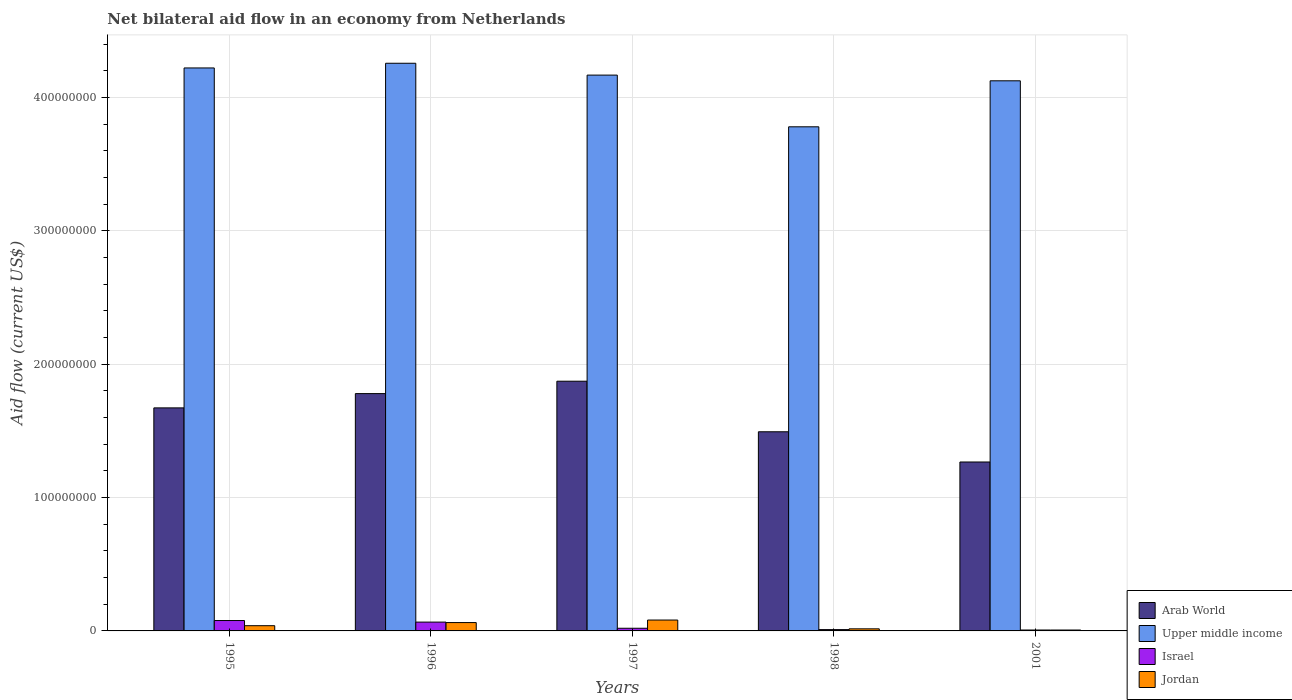Are the number of bars per tick equal to the number of legend labels?
Your response must be concise. Yes. Are the number of bars on each tick of the X-axis equal?
Give a very brief answer. Yes. How many bars are there on the 3rd tick from the right?
Your answer should be compact. 4. What is the net bilateral aid flow in Israel in 1998?
Provide a short and direct response. 9.90e+05. Across all years, what is the maximum net bilateral aid flow in Arab World?
Provide a short and direct response. 1.87e+08. Across all years, what is the minimum net bilateral aid flow in Jordan?
Ensure brevity in your answer.  6.70e+05. In which year was the net bilateral aid flow in Arab World maximum?
Make the answer very short. 1997. In which year was the net bilateral aid flow in Upper middle income minimum?
Keep it short and to the point. 1998. What is the total net bilateral aid flow in Jordan in the graph?
Ensure brevity in your answer.  2.06e+07. What is the difference between the net bilateral aid flow in Israel in 1997 and that in 2001?
Ensure brevity in your answer.  1.31e+06. What is the difference between the net bilateral aid flow in Jordan in 1997 and the net bilateral aid flow in Israel in 1996?
Your answer should be very brief. 1.54e+06. What is the average net bilateral aid flow in Upper middle income per year?
Your answer should be compact. 4.11e+08. In the year 1998, what is the difference between the net bilateral aid flow in Arab World and net bilateral aid flow in Israel?
Keep it short and to the point. 1.48e+08. What is the ratio of the net bilateral aid flow in Arab World in 1996 to that in 2001?
Your answer should be compact. 1.4. Is the difference between the net bilateral aid flow in Arab World in 1995 and 2001 greater than the difference between the net bilateral aid flow in Israel in 1995 and 2001?
Make the answer very short. Yes. What is the difference between the highest and the second highest net bilateral aid flow in Upper middle income?
Keep it short and to the point. 3.52e+06. What is the difference between the highest and the lowest net bilateral aid flow in Israel?
Ensure brevity in your answer.  7.11e+06. In how many years, is the net bilateral aid flow in Arab World greater than the average net bilateral aid flow in Arab World taken over all years?
Your response must be concise. 3. Is the sum of the net bilateral aid flow in Upper middle income in 1996 and 1997 greater than the maximum net bilateral aid flow in Arab World across all years?
Ensure brevity in your answer.  Yes. Is it the case that in every year, the sum of the net bilateral aid flow in Jordan and net bilateral aid flow in Israel is greater than the sum of net bilateral aid flow in Arab World and net bilateral aid flow in Upper middle income?
Keep it short and to the point. No. What does the 3rd bar from the right in 1997 represents?
Offer a terse response. Upper middle income. How many years are there in the graph?
Your response must be concise. 5. What is the difference between two consecutive major ticks on the Y-axis?
Provide a short and direct response. 1.00e+08. Are the values on the major ticks of Y-axis written in scientific E-notation?
Give a very brief answer. No. Does the graph contain grids?
Your response must be concise. Yes. How many legend labels are there?
Ensure brevity in your answer.  4. How are the legend labels stacked?
Make the answer very short. Vertical. What is the title of the graph?
Your response must be concise. Net bilateral aid flow in an economy from Netherlands. Does "Virgin Islands" appear as one of the legend labels in the graph?
Ensure brevity in your answer.  No. What is the Aid flow (current US$) in Arab World in 1995?
Make the answer very short. 1.67e+08. What is the Aid flow (current US$) of Upper middle income in 1995?
Your answer should be compact. 4.22e+08. What is the Aid flow (current US$) in Israel in 1995?
Make the answer very short. 7.80e+06. What is the Aid flow (current US$) in Jordan in 1995?
Provide a short and direct response. 3.92e+06. What is the Aid flow (current US$) of Arab World in 1996?
Your answer should be compact. 1.78e+08. What is the Aid flow (current US$) in Upper middle income in 1996?
Your response must be concise. 4.26e+08. What is the Aid flow (current US$) in Israel in 1996?
Ensure brevity in your answer.  6.62e+06. What is the Aid flow (current US$) in Jordan in 1996?
Your response must be concise. 6.26e+06. What is the Aid flow (current US$) of Arab World in 1997?
Your response must be concise. 1.87e+08. What is the Aid flow (current US$) of Upper middle income in 1997?
Offer a terse response. 4.17e+08. What is the Aid flow (current US$) in Jordan in 1997?
Provide a short and direct response. 8.16e+06. What is the Aid flow (current US$) of Arab World in 1998?
Give a very brief answer. 1.49e+08. What is the Aid flow (current US$) of Upper middle income in 1998?
Give a very brief answer. 3.78e+08. What is the Aid flow (current US$) in Israel in 1998?
Offer a terse response. 9.90e+05. What is the Aid flow (current US$) of Jordan in 1998?
Keep it short and to the point. 1.56e+06. What is the Aid flow (current US$) of Arab World in 2001?
Your answer should be compact. 1.27e+08. What is the Aid flow (current US$) in Upper middle income in 2001?
Provide a short and direct response. 4.13e+08. What is the Aid flow (current US$) of Israel in 2001?
Provide a succinct answer. 6.90e+05. What is the Aid flow (current US$) in Jordan in 2001?
Offer a very short reply. 6.70e+05. Across all years, what is the maximum Aid flow (current US$) of Arab World?
Provide a short and direct response. 1.87e+08. Across all years, what is the maximum Aid flow (current US$) in Upper middle income?
Your answer should be very brief. 4.26e+08. Across all years, what is the maximum Aid flow (current US$) of Israel?
Your answer should be very brief. 7.80e+06. Across all years, what is the maximum Aid flow (current US$) in Jordan?
Ensure brevity in your answer.  8.16e+06. Across all years, what is the minimum Aid flow (current US$) of Arab World?
Your answer should be compact. 1.27e+08. Across all years, what is the minimum Aid flow (current US$) in Upper middle income?
Offer a very short reply. 3.78e+08. Across all years, what is the minimum Aid flow (current US$) in Israel?
Offer a terse response. 6.90e+05. Across all years, what is the minimum Aid flow (current US$) in Jordan?
Ensure brevity in your answer.  6.70e+05. What is the total Aid flow (current US$) in Arab World in the graph?
Ensure brevity in your answer.  8.09e+08. What is the total Aid flow (current US$) of Upper middle income in the graph?
Your response must be concise. 2.06e+09. What is the total Aid flow (current US$) of Israel in the graph?
Ensure brevity in your answer.  1.81e+07. What is the total Aid flow (current US$) in Jordan in the graph?
Ensure brevity in your answer.  2.06e+07. What is the difference between the Aid flow (current US$) in Arab World in 1995 and that in 1996?
Offer a terse response. -1.07e+07. What is the difference between the Aid flow (current US$) of Upper middle income in 1995 and that in 1996?
Offer a terse response. -3.52e+06. What is the difference between the Aid flow (current US$) of Israel in 1995 and that in 1996?
Your answer should be very brief. 1.18e+06. What is the difference between the Aid flow (current US$) in Jordan in 1995 and that in 1996?
Provide a short and direct response. -2.34e+06. What is the difference between the Aid flow (current US$) of Arab World in 1995 and that in 1997?
Offer a terse response. -2.00e+07. What is the difference between the Aid flow (current US$) of Upper middle income in 1995 and that in 1997?
Provide a short and direct response. 5.36e+06. What is the difference between the Aid flow (current US$) in Israel in 1995 and that in 1997?
Your answer should be very brief. 5.80e+06. What is the difference between the Aid flow (current US$) in Jordan in 1995 and that in 1997?
Offer a terse response. -4.24e+06. What is the difference between the Aid flow (current US$) of Arab World in 1995 and that in 1998?
Ensure brevity in your answer.  1.79e+07. What is the difference between the Aid flow (current US$) of Upper middle income in 1995 and that in 1998?
Offer a very short reply. 4.41e+07. What is the difference between the Aid flow (current US$) in Israel in 1995 and that in 1998?
Make the answer very short. 6.81e+06. What is the difference between the Aid flow (current US$) in Jordan in 1995 and that in 1998?
Keep it short and to the point. 2.36e+06. What is the difference between the Aid flow (current US$) in Arab World in 1995 and that in 2001?
Ensure brevity in your answer.  4.06e+07. What is the difference between the Aid flow (current US$) of Upper middle income in 1995 and that in 2001?
Provide a short and direct response. 9.64e+06. What is the difference between the Aid flow (current US$) of Israel in 1995 and that in 2001?
Your answer should be very brief. 7.11e+06. What is the difference between the Aid flow (current US$) in Jordan in 1995 and that in 2001?
Provide a short and direct response. 3.25e+06. What is the difference between the Aid flow (current US$) of Arab World in 1996 and that in 1997?
Offer a very short reply. -9.29e+06. What is the difference between the Aid flow (current US$) of Upper middle income in 1996 and that in 1997?
Provide a succinct answer. 8.88e+06. What is the difference between the Aid flow (current US$) of Israel in 1996 and that in 1997?
Keep it short and to the point. 4.62e+06. What is the difference between the Aid flow (current US$) in Jordan in 1996 and that in 1997?
Ensure brevity in your answer.  -1.90e+06. What is the difference between the Aid flow (current US$) in Arab World in 1996 and that in 1998?
Provide a short and direct response. 2.86e+07. What is the difference between the Aid flow (current US$) of Upper middle income in 1996 and that in 1998?
Your answer should be very brief. 4.77e+07. What is the difference between the Aid flow (current US$) in Israel in 1996 and that in 1998?
Keep it short and to the point. 5.63e+06. What is the difference between the Aid flow (current US$) in Jordan in 1996 and that in 1998?
Offer a very short reply. 4.70e+06. What is the difference between the Aid flow (current US$) in Arab World in 1996 and that in 2001?
Provide a short and direct response. 5.13e+07. What is the difference between the Aid flow (current US$) of Upper middle income in 1996 and that in 2001?
Provide a succinct answer. 1.32e+07. What is the difference between the Aid flow (current US$) in Israel in 1996 and that in 2001?
Offer a very short reply. 5.93e+06. What is the difference between the Aid flow (current US$) in Jordan in 1996 and that in 2001?
Give a very brief answer. 5.59e+06. What is the difference between the Aid flow (current US$) in Arab World in 1997 and that in 1998?
Your response must be concise. 3.79e+07. What is the difference between the Aid flow (current US$) of Upper middle income in 1997 and that in 1998?
Offer a terse response. 3.88e+07. What is the difference between the Aid flow (current US$) of Israel in 1997 and that in 1998?
Ensure brevity in your answer.  1.01e+06. What is the difference between the Aid flow (current US$) of Jordan in 1997 and that in 1998?
Your answer should be compact. 6.60e+06. What is the difference between the Aid flow (current US$) in Arab World in 1997 and that in 2001?
Your answer should be very brief. 6.06e+07. What is the difference between the Aid flow (current US$) of Upper middle income in 1997 and that in 2001?
Your answer should be very brief. 4.28e+06. What is the difference between the Aid flow (current US$) of Israel in 1997 and that in 2001?
Provide a short and direct response. 1.31e+06. What is the difference between the Aid flow (current US$) in Jordan in 1997 and that in 2001?
Offer a very short reply. 7.49e+06. What is the difference between the Aid flow (current US$) in Arab World in 1998 and that in 2001?
Ensure brevity in your answer.  2.27e+07. What is the difference between the Aid flow (current US$) in Upper middle income in 1998 and that in 2001?
Offer a very short reply. -3.45e+07. What is the difference between the Aid flow (current US$) of Jordan in 1998 and that in 2001?
Make the answer very short. 8.90e+05. What is the difference between the Aid flow (current US$) in Arab World in 1995 and the Aid flow (current US$) in Upper middle income in 1996?
Provide a succinct answer. -2.58e+08. What is the difference between the Aid flow (current US$) in Arab World in 1995 and the Aid flow (current US$) in Israel in 1996?
Provide a short and direct response. 1.61e+08. What is the difference between the Aid flow (current US$) of Arab World in 1995 and the Aid flow (current US$) of Jordan in 1996?
Ensure brevity in your answer.  1.61e+08. What is the difference between the Aid flow (current US$) in Upper middle income in 1995 and the Aid flow (current US$) in Israel in 1996?
Your answer should be very brief. 4.16e+08. What is the difference between the Aid flow (current US$) of Upper middle income in 1995 and the Aid flow (current US$) of Jordan in 1996?
Your response must be concise. 4.16e+08. What is the difference between the Aid flow (current US$) of Israel in 1995 and the Aid flow (current US$) of Jordan in 1996?
Make the answer very short. 1.54e+06. What is the difference between the Aid flow (current US$) in Arab World in 1995 and the Aid flow (current US$) in Upper middle income in 1997?
Ensure brevity in your answer.  -2.50e+08. What is the difference between the Aid flow (current US$) of Arab World in 1995 and the Aid flow (current US$) of Israel in 1997?
Offer a terse response. 1.65e+08. What is the difference between the Aid flow (current US$) of Arab World in 1995 and the Aid flow (current US$) of Jordan in 1997?
Offer a very short reply. 1.59e+08. What is the difference between the Aid flow (current US$) in Upper middle income in 1995 and the Aid flow (current US$) in Israel in 1997?
Your answer should be very brief. 4.20e+08. What is the difference between the Aid flow (current US$) in Upper middle income in 1995 and the Aid flow (current US$) in Jordan in 1997?
Make the answer very short. 4.14e+08. What is the difference between the Aid flow (current US$) in Israel in 1995 and the Aid flow (current US$) in Jordan in 1997?
Give a very brief answer. -3.60e+05. What is the difference between the Aid flow (current US$) in Arab World in 1995 and the Aid flow (current US$) in Upper middle income in 1998?
Offer a terse response. -2.11e+08. What is the difference between the Aid flow (current US$) of Arab World in 1995 and the Aid flow (current US$) of Israel in 1998?
Ensure brevity in your answer.  1.66e+08. What is the difference between the Aid flow (current US$) in Arab World in 1995 and the Aid flow (current US$) in Jordan in 1998?
Your response must be concise. 1.66e+08. What is the difference between the Aid flow (current US$) in Upper middle income in 1995 and the Aid flow (current US$) in Israel in 1998?
Give a very brief answer. 4.21e+08. What is the difference between the Aid flow (current US$) in Upper middle income in 1995 and the Aid flow (current US$) in Jordan in 1998?
Your answer should be very brief. 4.21e+08. What is the difference between the Aid flow (current US$) in Israel in 1995 and the Aid flow (current US$) in Jordan in 1998?
Your response must be concise. 6.24e+06. What is the difference between the Aid flow (current US$) in Arab World in 1995 and the Aid flow (current US$) in Upper middle income in 2001?
Your response must be concise. -2.45e+08. What is the difference between the Aid flow (current US$) in Arab World in 1995 and the Aid flow (current US$) in Israel in 2001?
Ensure brevity in your answer.  1.67e+08. What is the difference between the Aid flow (current US$) of Arab World in 1995 and the Aid flow (current US$) of Jordan in 2001?
Your answer should be compact. 1.67e+08. What is the difference between the Aid flow (current US$) of Upper middle income in 1995 and the Aid flow (current US$) of Israel in 2001?
Offer a very short reply. 4.22e+08. What is the difference between the Aid flow (current US$) in Upper middle income in 1995 and the Aid flow (current US$) in Jordan in 2001?
Offer a very short reply. 4.22e+08. What is the difference between the Aid flow (current US$) of Israel in 1995 and the Aid flow (current US$) of Jordan in 2001?
Provide a succinct answer. 7.13e+06. What is the difference between the Aid flow (current US$) in Arab World in 1996 and the Aid flow (current US$) in Upper middle income in 1997?
Provide a short and direct response. -2.39e+08. What is the difference between the Aid flow (current US$) in Arab World in 1996 and the Aid flow (current US$) in Israel in 1997?
Offer a very short reply. 1.76e+08. What is the difference between the Aid flow (current US$) in Arab World in 1996 and the Aid flow (current US$) in Jordan in 1997?
Make the answer very short. 1.70e+08. What is the difference between the Aid flow (current US$) in Upper middle income in 1996 and the Aid flow (current US$) in Israel in 1997?
Keep it short and to the point. 4.24e+08. What is the difference between the Aid flow (current US$) in Upper middle income in 1996 and the Aid flow (current US$) in Jordan in 1997?
Ensure brevity in your answer.  4.18e+08. What is the difference between the Aid flow (current US$) of Israel in 1996 and the Aid flow (current US$) of Jordan in 1997?
Keep it short and to the point. -1.54e+06. What is the difference between the Aid flow (current US$) of Arab World in 1996 and the Aid flow (current US$) of Upper middle income in 1998?
Ensure brevity in your answer.  -2.00e+08. What is the difference between the Aid flow (current US$) in Arab World in 1996 and the Aid flow (current US$) in Israel in 1998?
Keep it short and to the point. 1.77e+08. What is the difference between the Aid flow (current US$) in Arab World in 1996 and the Aid flow (current US$) in Jordan in 1998?
Offer a very short reply. 1.76e+08. What is the difference between the Aid flow (current US$) in Upper middle income in 1996 and the Aid flow (current US$) in Israel in 1998?
Your response must be concise. 4.25e+08. What is the difference between the Aid flow (current US$) in Upper middle income in 1996 and the Aid flow (current US$) in Jordan in 1998?
Offer a terse response. 4.24e+08. What is the difference between the Aid flow (current US$) of Israel in 1996 and the Aid flow (current US$) of Jordan in 1998?
Make the answer very short. 5.06e+06. What is the difference between the Aid flow (current US$) of Arab World in 1996 and the Aid flow (current US$) of Upper middle income in 2001?
Offer a very short reply. -2.35e+08. What is the difference between the Aid flow (current US$) in Arab World in 1996 and the Aid flow (current US$) in Israel in 2001?
Offer a terse response. 1.77e+08. What is the difference between the Aid flow (current US$) in Arab World in 1996 and the Aid flow (current US$) in Jordan in 2001?
Give a very brief answer. 1.77e+08. What is the difference between the Aid flow (current US$) in Upper middle income in 1996 and the Aid flow (current US$) in Israel in 2001?
Your answer should be very brief. 4.25e+08. What is the difference between the Aid flow (current US$) of Upper middle income in 1996 and the Aid flow (current US$) of Jordan in 2001?
Give a very brief answer. 4.25e+08. What is the difference between the Aid flow (current US$) in Israel in 1996 and the Aid flow (current US$) in Jordan in 2001?
Provide a succinct answer. 5.95e+06. What is the difference between the Aid flow (current US$) in Arab World in 1997 and the Aid flow (current US$) in Upper middle income in 1998?
Your response must be concise. -1.91e+08. What is the difference between the Aid flow (current US$) of Arab World in 1997 and the Aid flow (current US$) of Israel in 1998?
Provide a succinct answer. 1.86e+08. What is the difference between the Aid flow (current US$) in Arab World in 1997 and the Aid flow (current US$) in Jordan in 1998?
Offer a very short reply. 1.86e+08. What is the difference between the Aid flow (current US$) in Upper middle income in 1997 and the Aid flow (current US$) in Israel in 1998?
Your answer should be compact. 4.16e+08. What is the difference between the Aid flow (current US$) in Upper middle income in 1997 and the Aid flow (current US$) in Jordan in 1998?
Your answer should be very brief. 4.15e+08. What is the difference between the Aid flow (current US$) of Arab World in 1997 and the Aid flow (current US$) of Upper middle income in 2001?
Provide a succinct answer. -2.25e+08. What is the difference between the Aid flow (current US$) of Arab World in 1997 and the Aid flow (current US$) of Israel in 2001?
Your response must be concise. 1.87e+08. What is the difference between the Aid flow (current US$) in Arab World in 1997 and the Aid flow (current US$) in Jordan in 2001?
Offer a very short reply. 1.87e+08. What is the difference between the Aid flow (current US$) in Upper middle income in 1997 and the Aid flow (current US$) in Israel in 2001?
Make the answer very short. 4.16e+08. What is the difference between the Aid flow (current US$) of Upper middle income in 1997 and the Aid flow (current US$) of Jordan in 2001?
Provide a short and direct response. 4.16e+08. What is the difference between the Aid flow (current US$) in Israel in 1997 and the Aid flow (current US$) in Jordan in 2001?
Provide a succinct answer. 1.33e+06. What is the difference between the Aid flow (current US$) in Arab World in 1998 and the Aid flow (current US$) in Upper middle income in 2001?
Provide a succinct answer. -2.63e+08. What is the difference between the Aid flow (current US$) in Arab World in 1998 and the Aid flow (current US$) in Israel in 2001?
Offer a terse response. 1.49e+08. What is the difference between the Aid flow (current US$) in Arab World in 1998 and the Aid flow (current US$) in Jordan in 2001?
Your answer should be compact. 1.49e+08. What is the difference between the Aid flow (current US$) in Upper middle income in 1998 and the Aid flow (current US$) in Israel in 2001?
Offer a very short reply. 3.77e+08. What is the difference between the Aid flow (current US$) of Upper middle income in 1998 and the Aid flow (current US$) of Jordan in 2001?
Your answer should be compact. 3.77e+08. What is the difference between the Aid flow (current US$) in Israel in 1998 and the Aid flow (current US$) in Jordan in 2001?
Offer a very short reply. 3.20e+05. What is the average Aid flow (current US$) in Arab World per year?
Keep it short and to the point. 1.62e+08. What is the average Aid flow (current US$) of Upper middle income per year?
Your answer should be very brief. 4.11e+08. What is the average Aid flow (current US$) of Israel per year?
Your answer should be compact. 3.62e+06. What is the average Aid flow (current US$) in Jordan per year?
Your answer should be very brief. 4.11e+06. In the year 1995, what is the difference between the Aid flow (current US$) in Arab World and Aid flow (current US$) in Upper middle income?
Your answer should be compact. -2.55e+08. In the year 1995, what is the difference between the Aid flow (current US$) of Arab World and Aid flow (current US$) of Israel?
Your answer should be very brief. 1.59e+08. In the year 1995, what is the difference between the Aid flow (current US$) in Arab World and Aid flow (current US$) in Jordan?
Your answer should be very brief. 1.63e+08. In the year 1995, what is the difference between the Aid flow (current US$) in Upper middle income and Aid flow (current US$) in Israel?
Ensure brevity in your answer.  4.14e+08. In the year 1995, what is the difference between the Aid flow (current US$) of Upper middle income and Aid flow (current US$) of Jordan?
Ensure brevity in your answer.  4.18e+08. In the year 1995, what is the difference between the Aid flow (current US$) of Israel and Aid flow (current US$) of Jordan?
Your answer should be very brief. 3.88e+06. In the year 1996, what is the difference between the Aid flow (current US$) in Arab World and Aid flow (current US$) in Upper middle income?
Your answer should be compact. -2.48e+08. In the year 1996, what is the difference between the Aid flow (current US$) in Arab World and Aid flow (current US$) in Israel?
Make the answer very short. 1.71e+08. In the year 1996, what is the difference between the Aid flow (current US$) in Arab World and Aid flow (current US$) in Jordan?
Ensure brevity in your answer.  1.72e+08. In the year 1996, what is the difference between the Aid flow (current US$) in Upper middle income and Aid flow (current US$) in Israel?
Give a very brief answer. 4.19e+08. In the year 1996, what is the difference between the Aid flow (current US$) of Upper middle income and Aid flow (current US$) of Jordan?
Your response must be concise. 4.19e+08. In the year 1996, what is the difference between the Aid flow (current US$) in Israel and Aid flow (current US$) in Jordan?
Offer a very short reply. 3.60e+05. In the year 1997, what is the difference between the Aid flow (current US$) of Arab World and Aid flow (current US$) of Upper middle income?
Your answer should be very brief. -2.30e+08. In the year 1997, what is the difference between the Aid flow (current US$) in Arab World and Aid flow (current US$) in Israel?
Your response must be concise. 1.85e+08. In the year 1997, what is the difference between the Aid flow (current US$) in Arab World and Aid flow (current US$) in Jordan?
Your response must be concise. 1.79e+08. In the year 1997, what is the difference between the Aid flow (current US$) of Upper middle income and Aid flow (current US$) of Israel?
Ensure brevity in your answer.  4.15e+08. In the year 1997, what is the difference between the Aid flow (current US$) of Upper middle income and Aid flow (current US$) of Jordan?
Ensure brevity in your answer.  4.09e+08. In the year 1997, what is the difference between the Aid flow (current US$) of Israel and Aid flow (current US$) of Jordan?
Keep it short and to the point. -6.16e+06. In the year 1998, what is the difference between the Aid flow (current US$) of Arab World and Aid flow (current US$) of Upper middle income?
Offer a very short reply. -2.29e+08. In the year 1998, what is the difference between the Aid flow (current US$) in Arab World and Aid flow (current US$) in Israel?
Your answer should be compact. 1.48e+08. In the year 1998, what is the difference between the Aid flow (current US$) of Arab World and Aid flow (current US$) of Jordan?
Keep it short and to the point. 1.48e+08. In the year 1998, what is the difference between the Aid flow (current US$) in Upper middle income and Aid flow (current US$) in Israel?
Ensure brevity in your answer.  3.77e+08. In the year 1998, what is the difference between the Aid flow (current US$) in Upper middle income and Aid flow (current US$) in Jordan?
Your answer should be compact. 3.77e+08. In the year 1998, what is the difference between the Aid flow (current US$) of Israel and Aid flow (current US$) of Jordan?
Offer a terse response. -5.70e+05. In the year 2001, what is the difference between the Aid flow (current US$) of Arab World and Aid flow (current US$) of Upper middle income?
Your answer should be very brief. -2.86e+08. In the year 2001, what is the difference between the Aid flow (current US$) of Arab World and Aid flow (current US$) of Israel?
Keep it short and to the point. 1.26e+08. In the year 2001, what is the difference between the Aid flow (current US$) of Arab World and Aid flow (current US$) of Jordan?
Keep it short and to the point. 1.26e+08. In the year 2001, what is the difference between the Aid flow (current US$) of Upper middle income and Aid flow (current US$) of Israel?
Your answer should be very brief. 4.12e+08. In the year 2001, what is the difference between the Aid flow (current US$) in Upper middle income and Aid flow (current US$) in Jordan?
Offer a terse response. 4.12e+08. In the year 2001, what is the difference between the Aid flow (current US$) in Israel and Aid flow (current US$) in Jordan?
Your answer should be very brief. 2.00e+04. What is the ratio of the Aid flow (current US$) in Arab World in 1995 to that in 1996?
Your answer should be compact. 0.94. What is the ratio of the Aid flow (current US$) in Israel in 1995 to that in 1996?
Provide a succinct answer. 1.18. What is the ratio of the Aid flow (current US$) of Jordan in 1995 to that in 1996?
Your answer should be compact. 0.63. What is the ratio of the Aid flow (current US$) in Arab World in 1995 to that in 1997?
Offer a terse response. 0.89. What is the ratio of the Aid flow (current US$) in Upper middle income in 1995 to that in 1997?
Keep it short and to the point. 1.01. What is the ratio of the Aid flow (current US$) in Jordan in 1995 to that in 1997?
Your answer should be compact. 0.48. What is the ratio of the Aid flow (current US$) in Arab World in 1995 to that in 1998?
Your response must be concise. 1.12. What is the ratio of the Aid flow (current US$) in Upper middle income in 1995 to that in 1998?
Make the answer very short. 1.12. What is the ratio of the Aid flow (current US$) in Israel in 1995 to that in 1998?
Your answer should be very brief. 7.88. What is the ratio of the Aid flow (current US$) in Jordan in 1995 to that in 1998?
Offer a terse response. 2.51. What is the ratio of the Aid flow (current US$) in Arab World in 1995 to that in 2001?
Offer a terse response. 1.32. What is the ratio of the Aid flow (current US$) of Upper middle income in 1995 to that in 2001?
Make the answer very short. 1.02. What is the ratio of the Aid flow (current US$) in Israel in 1995 to that in 2001?
Your answer should be very brief. 11.3. What is the ratio of the Aid flow (current US$) in Jordan in 1995 to that in 2001?
Provide a succinct answer. 5.85. What is the ratio of the Aid flow (current US$) of Arab World in 1996 to that in 1997?
Provide a succinct answer. 0.95. What is the ratio of the Aid flow (current US$) in Upper middle income in 1996 to that in 1997?
Offer a terse response. 1.02. What is the ratio of the Aid flow (current US$) of Israel in 1996 to that in 1997?
Give a very brief answer. 3.31. What is the ratio of the Aid flow (current US$) in Jordan in 1996 to that in 1997?
Keep it short and to the point. 0.77. What is the ratio of the Aid flow (current US$) of Arab World in 1996 to that in 1998?
Your response must be concise. 1.19. What is the ratio of the Aid flow (current US$) of Upper middle income in 1996 to that in 1998?
Provide a succinct answer. 1.13. What is the ratio of the Aid flow (current US$) in Israel in 1996 to that in 1998?
Your answer should be very brief. 6.69. What is the ratio of the Aid flow (current US$) of Jordan in 1996 to that in 1998?
Make the answer very short. 4.01. What is the ratio of the Aid flow (current US$) of Arab World in 1996 to that in 2001?
Your answer should be very brief. 1.4. What is the ratio of the Aid flow (current US$) in Upper middle income in 1996 to that in 2001?
Offer a terse response. 1.03. What is the ratio of the Aid flow (current US$) in Israel in 1996 to that in 2001?
Your response must be concise. 9.59. What is the ratio of the Aid flow (current US$) of Jordan in 1996 to that in 2001?
Your response must be concise. 9.34. What is the ratio of the Aid flow (current US$) in Arab World in 1997 to that in 1998?
Your answer should be compact. 1.25. What is the ratio of the Aid flow (current US$) in Upper middle income in 1997 to that in 1998?
Your answer should be compact. 1.1. What is the ratio of the Aid flow (current US$) of Israel in 1997 to that in 1998?
Make the answer very short. 2.02. What is the ratio of the Aid flow (current US$) in Jordan in 1997 to that in 1998?
Provide a short and direct response. 5.23. What is the ratio of the Aid flow (current US$) in Arab World in 1997 to that in 2001?
Offer a very short reply. 1.48. What is the ratio of the Aid flow (current US$) of Upper middle income in 1997 to that in 2001?
Make the answer very short. 1.01. What is the ratio of the Aid flow (current US$) of Israel in 1997 to that in 2001?
Ensure brevity in your answer.  2.9. What is the ratio of the Aid flow (current US$) of Jordan in 1997 to that in 2001?
Offer a very short reply. 12.18. What is the ratio of the Aid flow (current US$) in Arab World in 1998 to that in 2001?
Offer a terse response. 1.18. What is the ratio of the Aid flow (current US$) of Upper middle income in 1998 to that in 2001?
Keep it short and to the point. 0.92. What is the ratio of the Aid flow (current US$) in Israel in 1998 to that in 2001?
Offer a very short reply. 1.43. What is the ratio of the Aid flow (current US$) of Jordan in 1998 to that in 2001?
Keep it short and to the point. 2.33. What is the difference between the highest and the second highest Aid flow (current US$) of Arab World?
Make the answer very short. 9.29e+06. What is the difference between the highest and the second highest Aid flow (current US$) in Upper middle income?
Your response must be concise. 3.52e+06. What is the difference between the highest and the second highest Aid flow (current US$) of Israel?
Offer a very short reply. 1.18e+06. What is the difference between the highest and the second highest Aid flow (current US$) of Jordan?
Keep it short and to the point. 1.90e+06. What is the difference between the highest and the lowest Aid flow (current US$) of Arab World?
Your answer should be very brief. 6.06e+07. What is the difference between the highest and the lowest Aid flow (current US$) in Upper middle income?
Provide a succinct answer. 4.77e+07. What is the difference between the highest and the lowest Aid flow (current US$) in Israel?
Your answer should be very brief. 7.11e+06. What is the difference between the highest and the lowest Aid flow (current US$) of Jordan?
Give a very brief answer. 7.49e+06. 